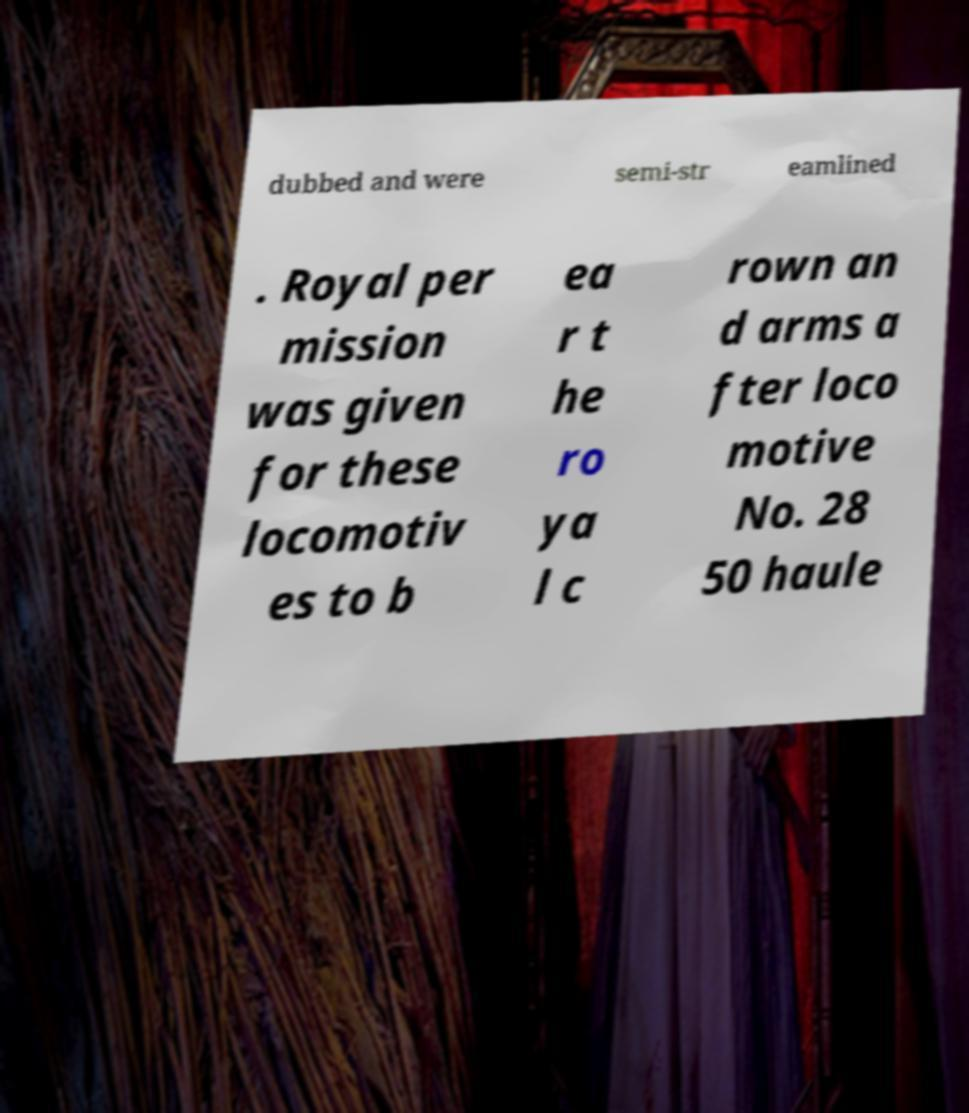Can you read and provide the text displayed in the image?This photo seems to have some interesting text. Can you extract and type it out for me? dubbed and were semi-str eamlined . Royal per mission was given for these locomotiv es to b ea r t he ro ya l c rown an d arms a fter loco motive No. 28 50 haule 